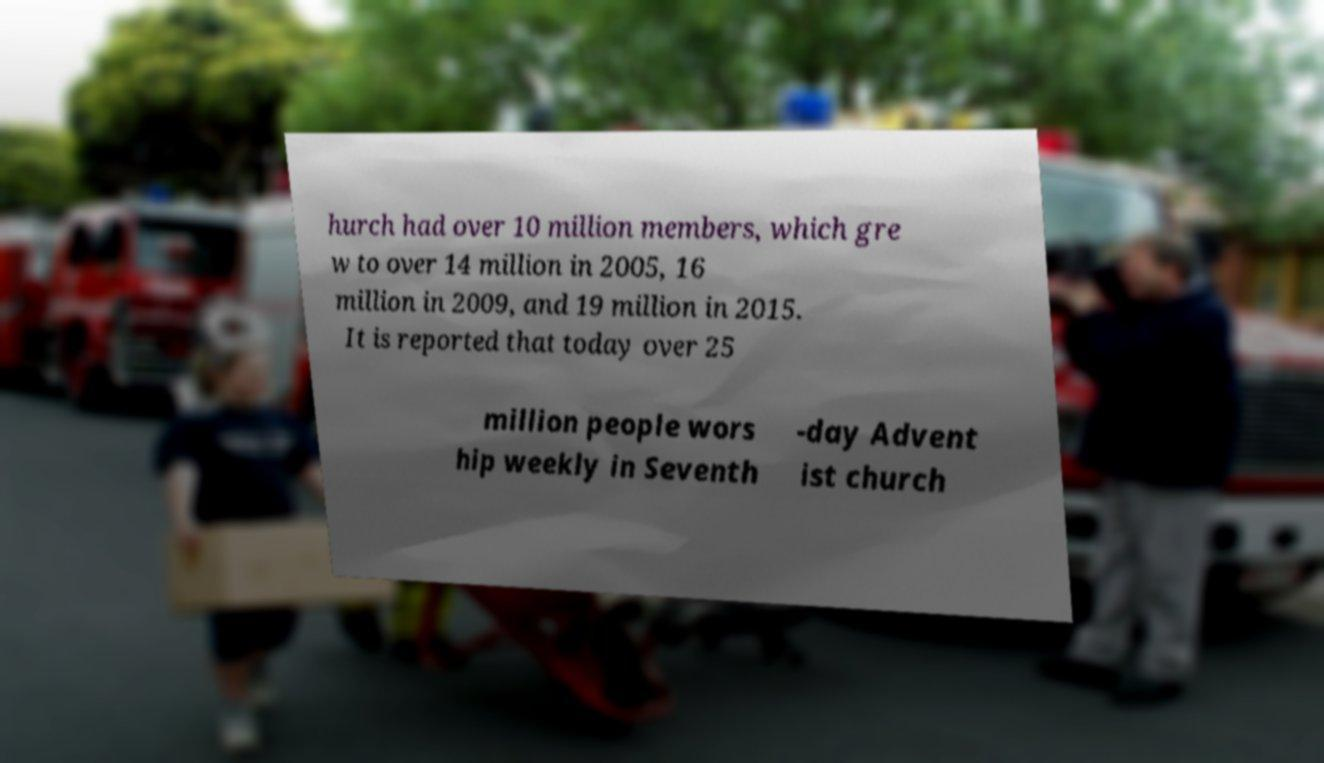For documentation purposes, I need the text within this image transcribed. Could you provide that? hurch had over 10 million members, which gre w to over 14 million in 2005, 16 million in 2009, and 19 million in 2015. It is reported that today over 25 million people wors hip weekly in Seventh -day Advent ist church 